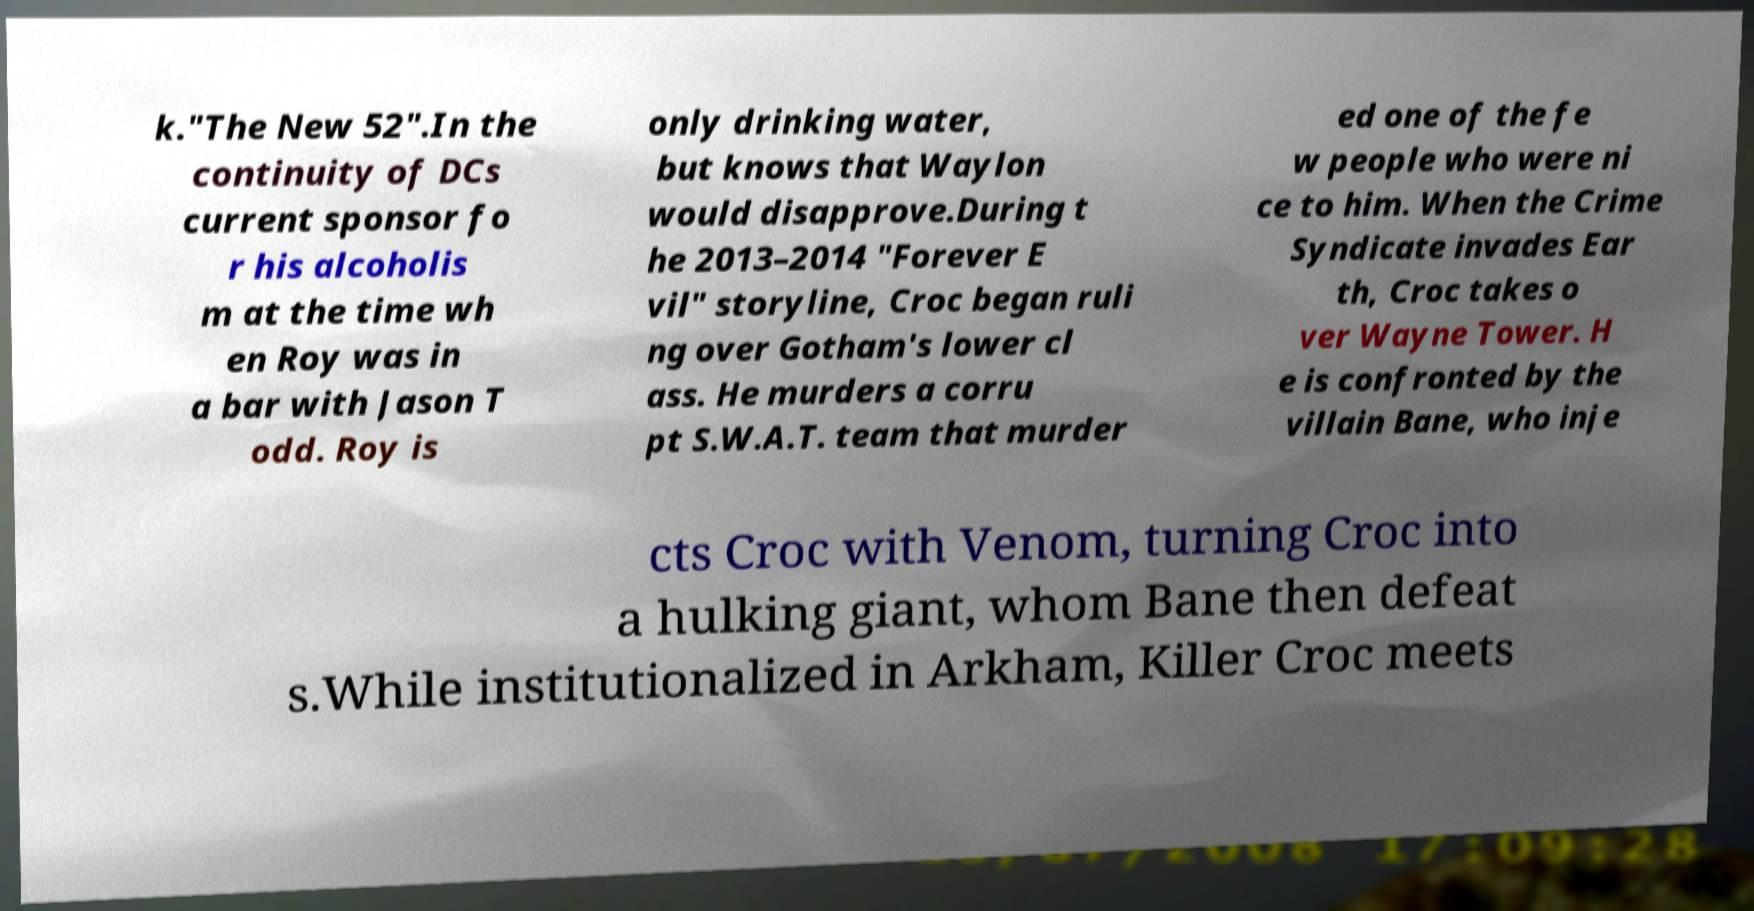Could you extract and type out the text from this image? k."The New 52".In the continuity of DCs current sponsor fo r his alcoholis m at the time wh en Roy was in a bar with Jason T odd. Roy is only drinking water, but knows that Waylon would disapprove.During t he 2013–2014 "Forever E vil" storyline, Croc began ruli ng over Gotham's lower cl ass. He murders a corru pt S.W.A.T. team that murder ed one of the fe w people who were ni ce to him. When the Crime Syndicate invades Ear th, Croc takes o ver Wayne Tower. H e is confronted by the villain Bane, who inje cts Croc with Venom, turning Croc into a hulking giant, whom Bane then defeat s.While institutionalized in Arkham, Killer Croc meets 